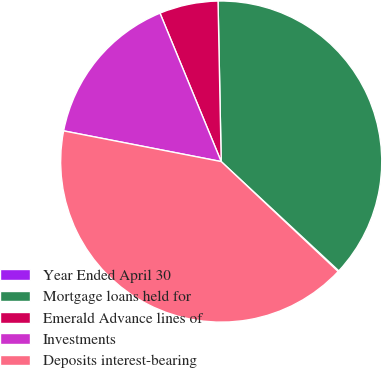<chart> <loc_0><loc_0><loc_500><loc_500><pie_chart><fcel>Year Ended April 30<fcel>Mortgage loans held for<fcel>Emerald Advance lines of<fcel>Investments<fcel>Deposits interest-bearing<nl><fcel>0.09%<fcel>37.23%<fcel>5.91%<fcel>15.71%<fcel>41.05%<nl></chart> 